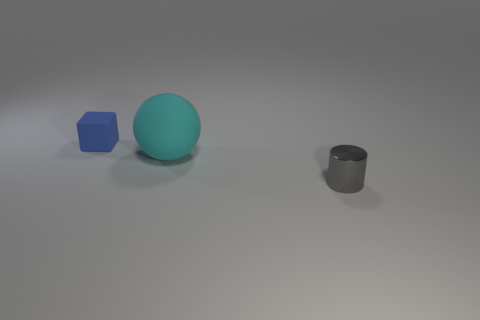Are there any big matte spheres of the same color as the small block?
Your answer should be compact. No. What number of red things are large matte things or matte objects?
Provide a short and direct response. 0. How many other objects are there of the same size as the gray cylinder?
Your answer should be very brief. 1. How many big objects are red metallic balls or cubes?
Offer a terse response. 0. Do the cyan sphere and the thing on the right side of the cyan matte ball have the same size?
Your response must be concise. No. The big object that is the same material as the blue cube is what shape?
Make the answer very short. Sphere. Are any small brown rubber balls visible?
Make the answer very short. No. Are there fewer small blocks that are on the left side of the blue rubber thing than gray metallic cylinders that are in front of the cylinder?
Provide a short and direct response. No. What is the shape of the rubber object that is on the right side of the tiny blue rubber block?
Offer a very short reply. Sphere. Are the big cyan sphere and the tiny blue block made of the same material?
Provide a succinct answer. Yes. 